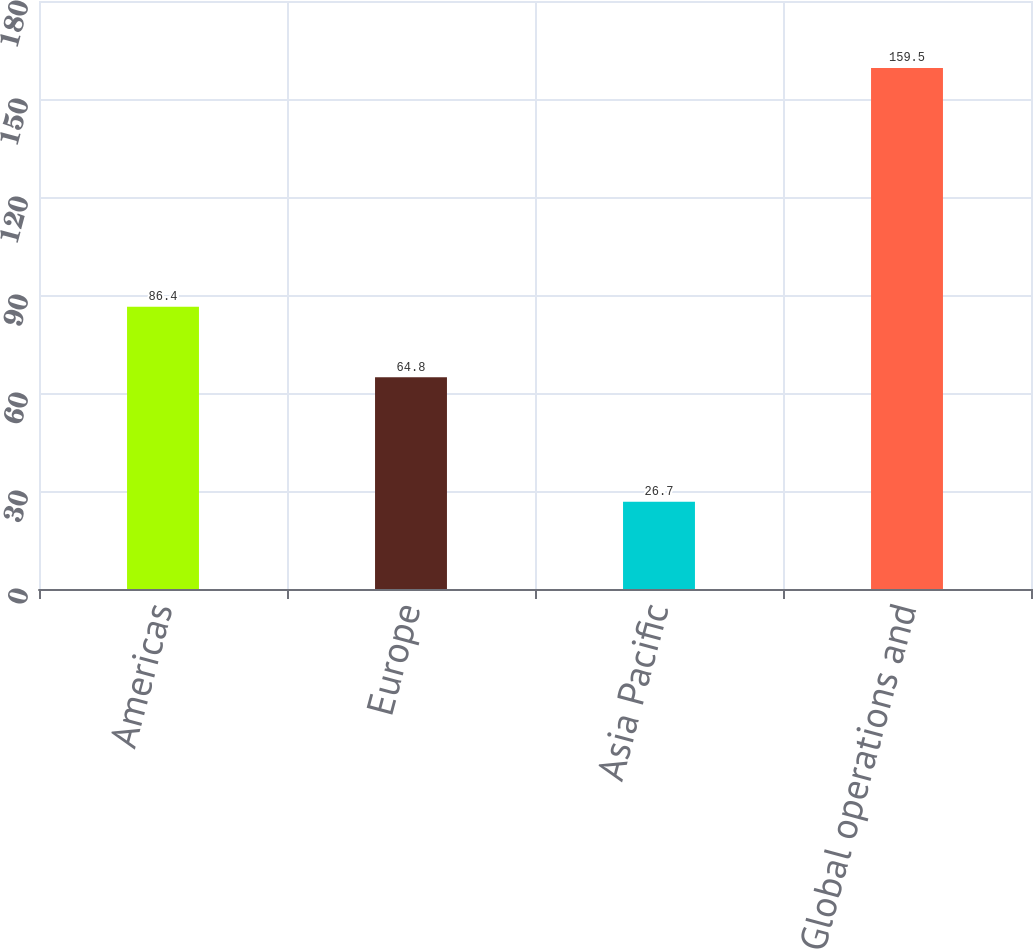Convert chart to OTSL. <chart><loc_0><loc_0><loc_500><loc_500><bar_chart><fcel>Americas<fcel>Europe<fcel>Asia Pacific<fcel>Global operations and<nl><fcel>86.4<fcel>64.8<fcel>26.7<fcel>159.5<nl></chart> 